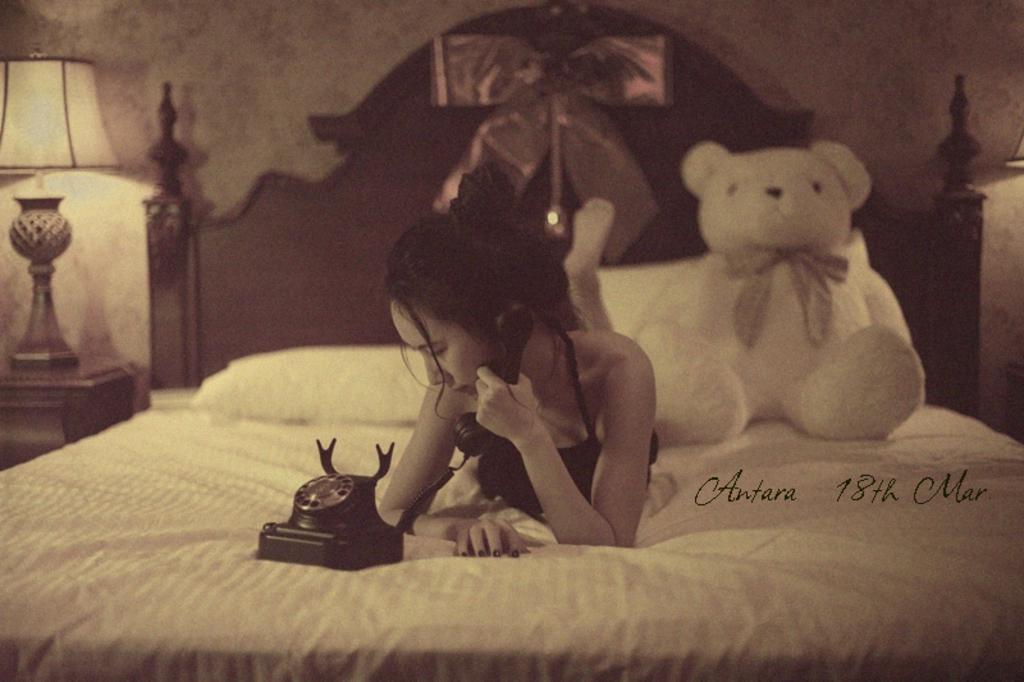Describe this image in one or two sentences. In this image, there is a bed contains contains teddy bear, telephone and person. There is a lamp in front of this wall. This person is wearing clothes. 